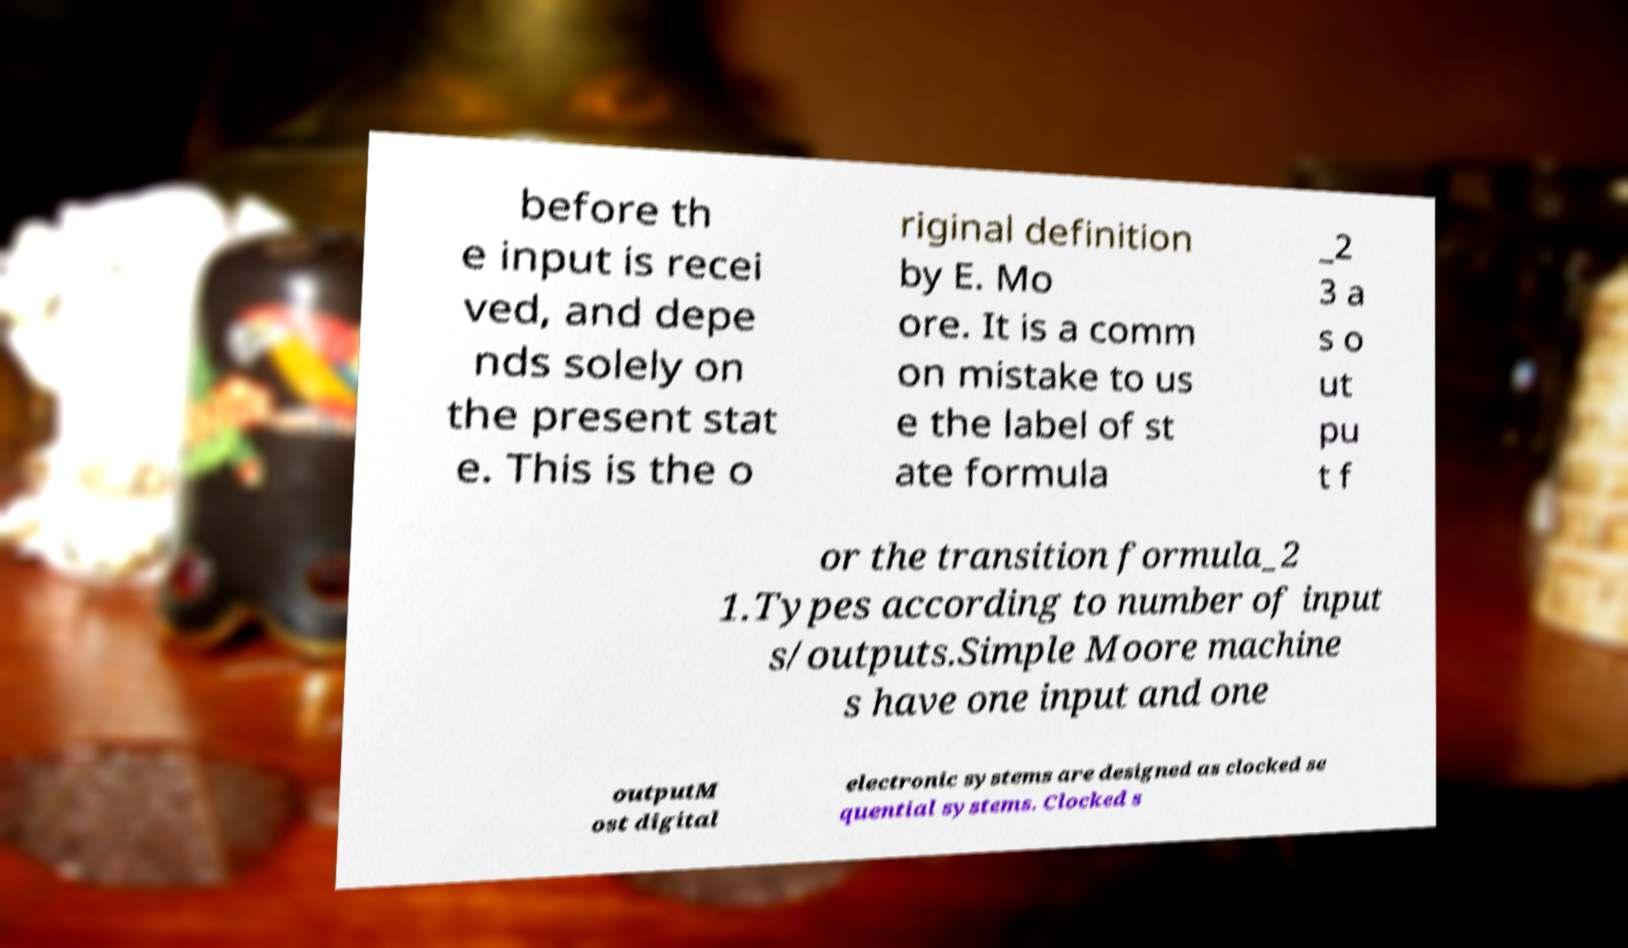Could you assist in decoding the text presented in this image and type it out clearly? before th e input is recei ved, and depe nds solely on the present stat e. This is the o riginal definition by E. Mo ore. It is a comm on mistake to us e the label of st ate formula _2 3 a s o ut pu t f or the transition formula_2 1.Types according to number of input s/outputs.Simple Moore machine s have one input and one outputM ost digital electronic systems are designed as clocked se quential systems. Clocked s 